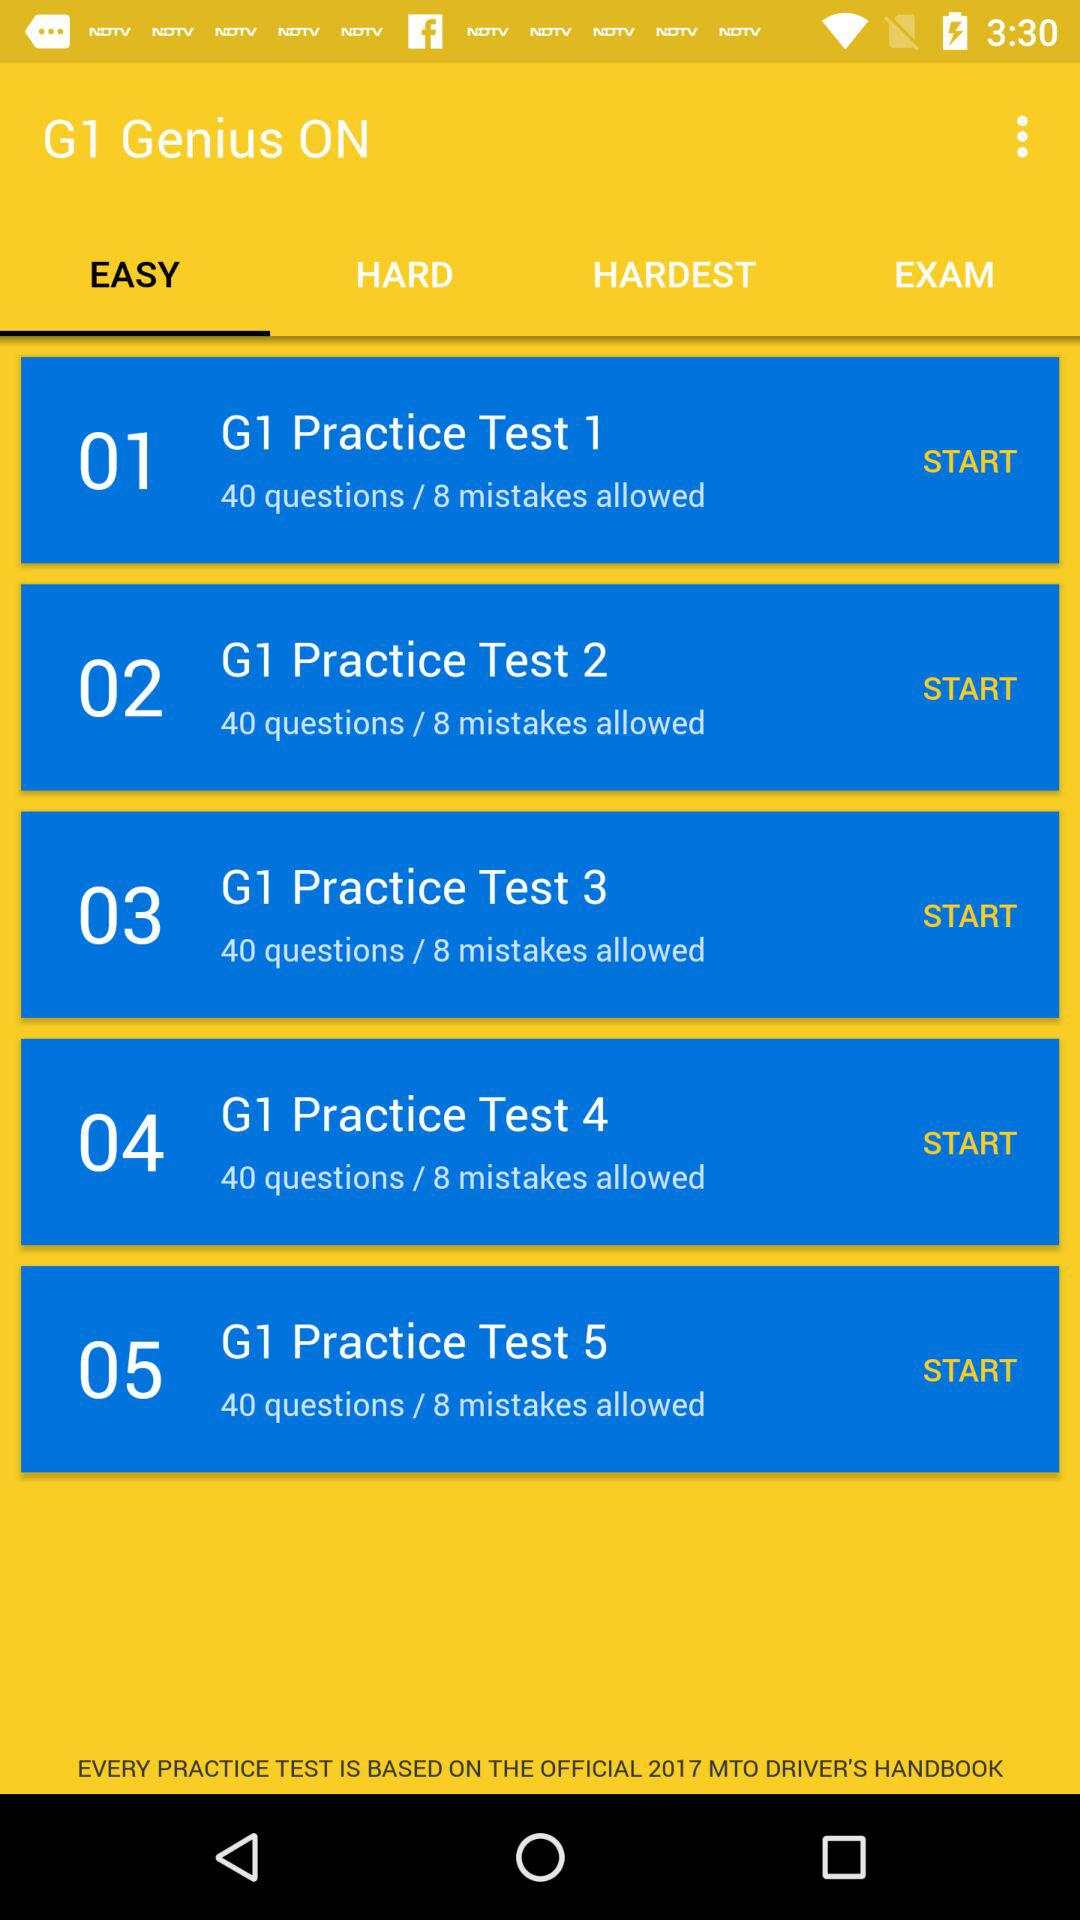How many mistakes are allowed in "G1 Practice Test 3"? There are 8 mistakes allowed. 